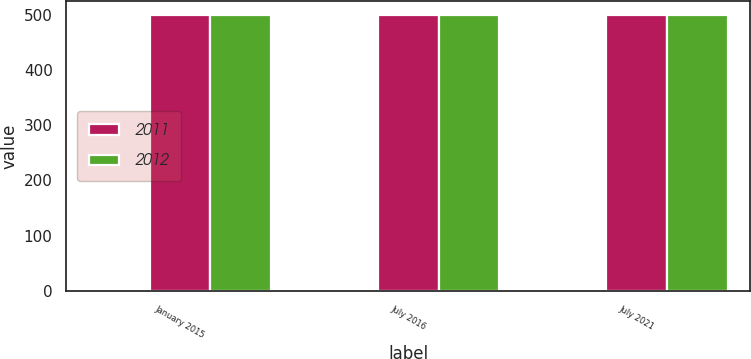Convert chart to OTSL. <chart><loc_0><loc_0><loc_500><loc_500><stacked_bar_chart><ecel><fcel>January 2015<fcel>July 2016<fcel>July 2021<nl><fcel>nan<fcel>1.38<fcel>2.25<fcel>3.88<nl><fcel>2011<fcel>499<fcel>499<fcel>499<nl><fcel>2012<fcel>500<fcel>500<fcel>499<nl></chart> 